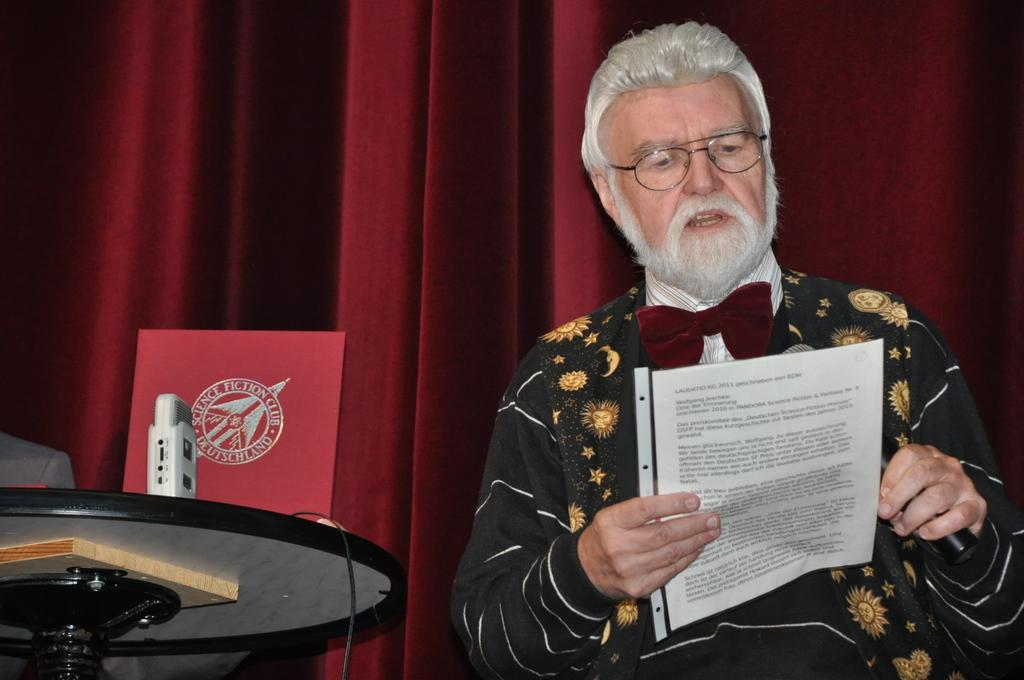What is the person on the right side of the image holding? The person is holding a microphone and a paper. What might the person be doing with the microphone and paper? The person might be giving a speech or presentation, as they are holding a microphone and a paper. What is located on the left side of the image? There is a stand on the left side of the image. What can be seen in the background of the image? There are curtains visible in the background of the image. Where is the drawer located in the image? There is no drawer present in the image. What type of balls can be seen in the image? There are no balls present in the image. 